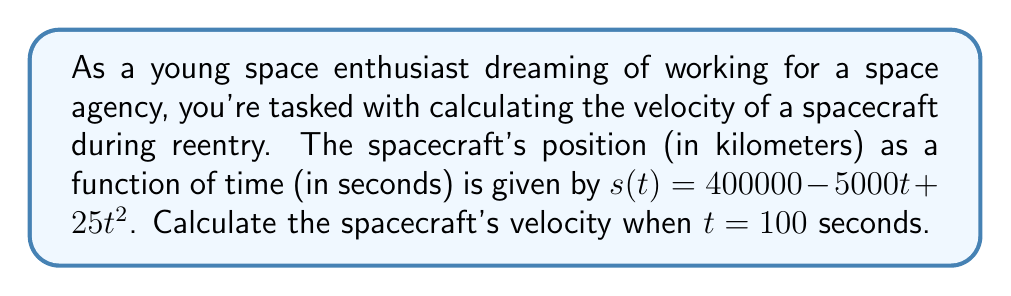Solve this math problem. Let's approach this step-by-step:

1) The velocity of an object is the derivative of its position function with respect to time. So, we need to find $v(t) = \frac{d}{dt}s(t)$.

2) Given: $s(t) = 400000 - 5000t + 25t^2$

3) To find the derivative, we apply the power rule:
   $$\frac{d}{dt}(400000) = 0$$
   $$\frac{d}{dt}(-5000t) = -5000$$
   $$\frac{d}{dt}(25t^2) = 25 \cdot 2t = 50t$$

4) Combining these terms, we get the velocity function:
   $$v(t) = -5000 + 50t$$

5) Now, we need to find the velocity when $t = 100$ seconds:
   $$v(100) = -5000 + 50(100)$$
   $$v(100) = -5000 + 5000$$
   $$v(100) = 0$$

6) The units of velocity are kilometers per second (km/s), as the position was given in kilometers and time in seconds.
Answer: 0 km/s 